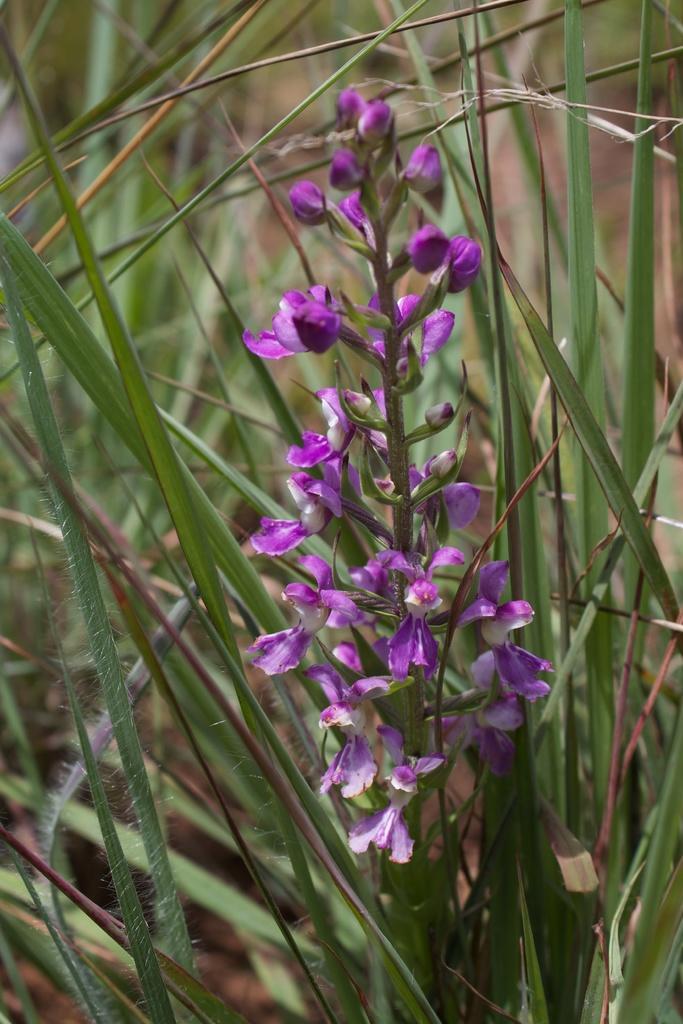How would you summarize this image in a sentence or two? This picture shows plants and we see purple color flowers. 